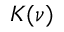<formula> <loc_0><loc_0><loc_500><loc_500>K ( \nu )</formula> 